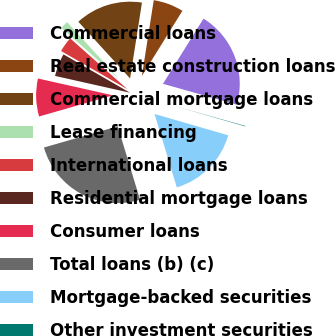<chart> <loc_0><loc_0><loc_500><loc_500><pie_chart><fcel>Commercial loans<fcel>Real estate construction loans<fcel>Commercial mortgage loans<fcel>Lease financing<fcel>International loans<fcel>Residential mortgage loans<fcel>Consumer loans<fcel>Total loans (b) (c)<fcel>Mortgage-backed securities<fcel>Other investment securities<nl><fcel>20.53%<fcel>6.38%<fcel>14.24%<fcel>1.67%<fcel>3.24%<fcel>4.81%<fcel>7.96%<fcel>25.25%<fcel>15.82%<fcel>0.1%<nl></chart> 